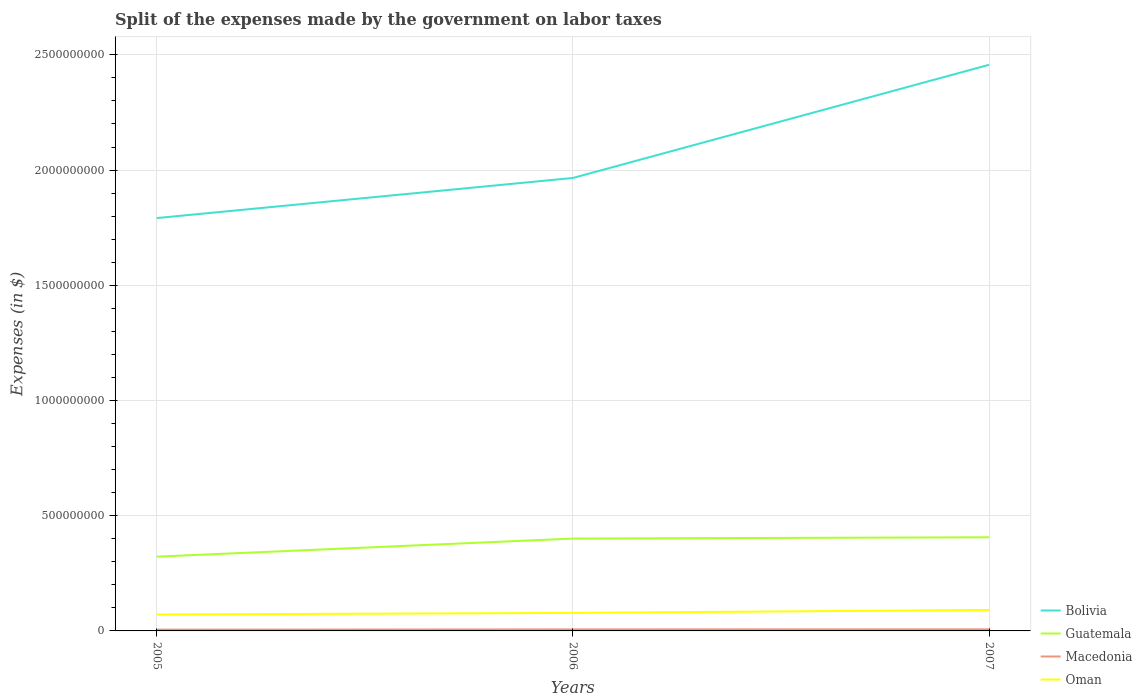Across all years, what is the maximum expenses made by the government on labor taxes in Oman?
Ensure brevity in your answer.  7.12e+07. What is the total expenses made by the government on labor taxes in Macedonia in the graph?
Ensure brevity in your answer.  -9.33e+05. What is the difference between the highest and the second highest expenses made by the government on labor taxes in Guatemala?
Provide a succinct answer. 8.40e+07. Is the expenses made by the government on labor taxes in Guatemala strictly greater than the expenses made by the government on labor taxes in Macedonia over the years?
Give a very brief answer. No. How many lines are there?
Keep it short and to the point. 4. How many years are there in the graph?
Your answer should be compact. 3. Are the values on the major ticks of Y-axis written in scientific E-notation?
Provide a short and direct response. No. Does the graph contain grids?
Your answer should be compact. Yes. Where does the legend appear in the graph?
Make the answer very short. Bottom right. How are the legend labels stacked?
Give a very brief answer. Vertical. What is the title of the graph?
Your answer should be compact. Split of the expenses made by the government on labor taxes. Does "Sint Maarten (Dutch part)" appear as one of the legend labels in the graph?
Offer a terse response. No. What is the label or title of the X-axis?
Your response must be concise. Years. What is the label or title of the Y-axis?
Provide a succinct answer. Expenses (in $). What is the Expenses (in $) of Bolivia in 2005?
Provide a succinct answer. 1.79e+09. What is the Expenses (in $) of Guatemala in 2005?
Make the answer very short. 3.22e+08. What is the Expenses (in $) of Macedonia in 2005?
Your answer should be very brief. 5.64e+06. What is the Expenses (in $) in Oman in 2005?
Offer a terse response. 7.12e+07. What is the Expenses (in $) of Bolivia in 2006?
Make the answer very short. 1.97e+09. What is the Expenses (in $) in Guatemala in 2006?
Keep it short and to the point. 4.01e+08. What is the Expenses (in $) of Macedonia in 2006?
Your answer should be very brief. 6.58e+06. What is the Expenses (in $) in Oman in 2006?
Offer a very short reply. 7.82e+07. What is the Expenses (in $) in Bolivia in 2007?
Provide a short and direct response. 2.46e+09. What is the Expenses (in $) of Guatemala in 2007?
Offer a very short reply. 4.06e+08. What is the Expenses (in $) in Macedonia in 2007?
Ensure brevity in your answer.  6.93e+06. What is the Expenses (in $) in Oman in 2007?
Ensure brevity in your answer.  9.09e+07. Across all years, what is the maximum Expenses (in $) in Bolivia?
Make the answer very short. 2.46e+09. Across all years, what is the maximum Expenses (in $) of Guatemala?
Your response must be concise. 4.06e+08. Across all years, what is the maximum Expenses (in $) in Macedonia?
Offer a very short reply. 6.93e+06. Across all years, what is the maximum Expenses (in $) of Oman?
Offer a terse response. 9.09e+07. Across all years, what is the minimum Expenses (in $) of Bolivia?
Your answer should be compact. 1.79e+09. Across all years, what is the minimum Expenses (in $) in Guatemala?
Your answer should be very brief. 3.22e+08. Across all years, what is the minimum Expenses (in $) in Macedonia?
Your response must be concise. 5.64e+06. Across all years, what is the minimum Expenses (in $) in Oman?
Give a very brief answer. 7.12e+07. What is the total Expenses (in $) of Bolivia in the graph?
Ensure brevity in your answer.  6.21e+09. What is the total Expenses (in $) of Guatemala in the graph?
Provide a short and direct response. 1.13e+09. What is the total Expenses (in $) of Macedonia in the graph?
Offer a very short reply. 1.92e+07. What is the total Expenses (in $) of Oman in the graph?
Provide a short and direct response. 2.40e+08. What is the difference between the Expenses (in $) of Bolivia in 2005 and that in 2006?
Make the answer very short. -1.74e+08. What is the difference between the Expenses (in $) in Guatemala in 2005 and that in 2006?
Your answer should be very brief. -7.84e+07. What is the difference between the Expenses (in $) of Macedonia in 2005 and that in 2006?
Your response must be concise. -9.33e+05. What is the difference between the Expenses (in $) of Oman in 2005 and that in 2006?
Keep it short and to the point. -7.00e+06. What is the difference between the Expenses (in $) of Bolivia in 2005 and that in 2007?
Make the answer very short. -6.65e+08. What is the difference between the Expenses (in $) of Guatemala in 2005 and that in 2007?
Your answer should be very brief. -8.40e+07. What is the difference between the Expenses (in $) in Macedonia in 2005 and that in 2007?
Offer a terse response. -1.29e+06. What is the difference between the Expenses (in $) of Oman in 2005 and that in 2007?
Your response must be concise. -1.97e+07. What is the difference between the Expenses (in $) in Bolivia in 2006 and that in 2007?
Provide a short and direct response. -4.91e+08. What is the difference between the Expenses (in $) in Guatemala in 2006 and that in 2007?
Your response must be concise. -5.60e+06. What is the difference between the Expenses (in $) in Macedonia in 2006 and that in 2007?
Offer a terse response. -3.58e+05. What is the difference between the Expenses (in $) of Oman in 2006 and that in 2007?
Give a very brief answer. -1.27e+07. What is the difference between the Expenses (in $) in Bolivia in 2005 and the Expenses (in $) in Guatemala in 2006?
Ensure brevity in your answer.  1.39e+09. What is the difference between the Expenses (in $) of Bolivia in 2005 and the Expenses (in $) of Macedonia in 2006?
Offer a very short reply. 1.79e+09. What is the difference between the Expenses (in $) in Bolivia in 2005 and the Expenses (in $) in Oman in 2006?
Provide a short and direct response. 1.71e+09. What is the difference between the Expenses (in $) in Guatemala in 2005 and the Expenses (in $) in Macedonia in 2006?
Provide a short and direct response. 3.16e+08. What is the difference between the Expenses (in $) in Guatemala in 2005 and the Expenses (in $) in Oman in 2006?
Keep it short and to the point. 2.44e+08. What is the difference between the Expenses (in $) in Macedonia in 2005 and the Expenses (in $) in Oman in 2006?
Your answer should be very brief. -7.26e+07. What is the difference between the Expenses (in $) of Bolivia in 2005 and the Expenses (in $) of Guatemala in 2007?
Make the answer very short. 1.39e+09. What is the difference between the Expenses (in $) of Bolivia in 2005 and the Expenses (in $) of Macedonia in 2007?
Your answer should be very brief. 1.78e+09. What is the difference between the Expenses (in $) in Bolivia in 2005 and the Expenses (in $) in Oman in 2007?
Your response must be concise. 1.70e+09. What is the difference between the Expenses (in $) of Guatemala in 2005 and the Expenses (in $) of Macedonia in 2007?
Your answer should be compact. 3.15e+08. What is the difference between the Expenses (in $) of Guatemala in 2005 and the Expenses (in $) of Oman in 2007?
Offer a terse response. 2.31e+08. What is the difference between the Expenses (in $) in Macedonia in 2005 and the Expenses (in $) in Oman in 2007?
Make the answer very short. -8.53e+07. What is the difference between the Expenses (in $) in Bolivia in 2006 and the Expenses (in $) in Guatemala in 2007?
Give a very brief answer. 1.56e+09. What is the difference between the Expenses (in $) in Bolivia in 2006 and the Expenses (in $) in Macedonia in 2007?
Your response must be concise. 1.96e+09. What is the difference between the Expenses (in $) of Bolivia in 2006 and the Expenses (in $) of Oman in 2007?
Your answer should be very brief. 1.87e+09. What is the difference between the Expenses (in $) of Guatemala in 2006 and the Expenses (in $) of Macedonia in 2007?
Your answer should be compact. 3.94e+08. What is the difference between the Expenses (in $) of Guatemala in 2006 and the Expenses (in $) of Oman in 2007?
Ensure brevity in your answer.  3.10e+08. What is the difference between the Expenses (in $) in Macedonia in 2006 and the Expenses (in $) in Oman in 2007?
Your answer should be very brief. -8.43e+07. What is the average Expenses (in $) in Bolivia per year?
Offer a very short reply. 2.07e+09. What is the average Expenses (in $) in Guatemala per year?
Give a very brief answer. 3.77e+08. What is the average Expenses (in $) of Macedonia per year?
Keep it short and to the point. 6.38e+06. What is the average Expenses (in $) in Oman per year?
Offer a terse response. 8.01e+07. In the year 2005, what is the difference between the Expenses (in $) of Bolivia and Expenses (in $) of Guatemala?
Keep it short and to the point. 1.47e+09. In the year 2005, what is the difference between the Expenses (in $) in Bolivia and Expenses (in $) in Macedonia?
Your answer should be compact. 1.79e+09. In the year 2005, what is the difference between the Expenses (in $) of Bolivia and Expenses (in $) of Oman?
Your answer should be compact. 1.72e+09. In the year 2005, what is the difference between the Expenses (in $) in Guatemala and Expenses (in $) in Macedonia?
Ensure brevity in your answer.  3.17e+08. In the year 2005, what is the difference between the Expenses (in $) of Guatemala and Expenses (in $) of Oman?
Provide a succinct answer. 2.51e+08. In the year 2005, what is the difference between the Expenses (in $) of Macedonia and Expenses (in $) of Oman?
Your answer should be compact. -6.56e+07. In the year 2006, what is the difference between the Expenses (in $) of Bolivia and Expenses (in $) of Guatemala?
Give a very brief answer. 1.56e+09. In the year 2006, what is the difference between the Expenses (in $) in Bolivia and Expenses (in $) in Macedonia?
Your answer should be very brief. 1.96e+09. In the year 2006, what is the difference between the Expenses (in $) in Bolivia and Expenses (in $) in Oman?
Offer a terse response. 1.89e+09. In the year 2006, what is the difference between the Expenses (in $) of Guatemala and Expenses (in $) of Macedonia?
Ensure brevity in your answer.  3.94e+08. In the year 2006, what is the difference between the Expenses (in $) of Guatemala and Expenses (in $) of Oman?
Ensure brevity in your answer.  3.23e+08. In the year 2006, what is the difference between the Expenses (in $) of Macedonia and Expenses (in $) of Oman?
Your answer should be compact. -7.16e+07. In the year 2007, what is the difference between the Expenses (in $) of Bolivia and Expenses (in $) of Guatemala?
Ensure brevity in your answer.  2.05e+09. In the year 2007, what is the difference between the Expenses (in $) of Bolivia and Expenses (in $) of Macedonia?
Offer a terse response. 2.45e+09. In the year 2007, what is the difference between the Expenses (in $) of Bolivia and Expenses (in $) of Oman?
Provide a succinct answer. 2.37e+09. In the year 2007, what is the difference between the Expenses (in $) in Guatemala and Expenses (in $) in Macedonia?
Provide a short and direct response. 3.99e+08. In the year 2007, what is the difference between the Expenses (in $) of Guatemala and Expenses (in $) of Oman?
Make the answer very short. 3.16e+08. In the year 2007, what is the difference between the Expenses (in $) of Macedonia and Expenses (in $) of Oman?
Your answer should be very brief. -8.40e+07. What is the ratio of the Expenses (in $) of Bolivia in 2005 to that in 2006?
Make the answer very short. 0.91. What is the ratio of the Expenses (in $) of Guatemala in 2005 to that in 2006?
Keep it short and to the point. 0.8. What is the ratio of the Expenses (in $) of Macedonia in 2005 to that in 2006?
Your response must be concise. 0.86. What is the ratio of the Expenses (in $) of Oman in 2005 to that in 2006?
Ensure brevity in your answer.  0.91. What is the ratio of the Expenses (in $) of Bolivia in 2005 to that in 2007?
Ensure brevity in your answer.  0.73. What is the ratio of the Expenses (in $) in Guatemala in 2005 to that in 2007?
Your answer should be compact. 0.79. What is the ratio of the Expenses (in $) in Macedonia in 2005 to that in 2007?
Ensure brevity in your answer.  0.81. What is the ratio of the Expenses (in $) of Oman in 2005 to that in 2007?
Provide a short and direct response. 0.78. What is the ratio of the Expenses (in $) of Bolivia in 2006 to that in 2007?
Your answer should be compact. 0.8. What is the ratio of the Expenses (in $) of Guatemala in 2006 to that in 2007?
Make the answer very short. 0.99. What is the ratio of the Expenses (in $) of Macedonia in 2006 to that in 2007?
Provide a succinct answer. 0.95. What is the ratio of the Expenses (in $) of Oman in 2006 to that in 2007?
Your response must be concise. 0.86. What is the difference between the highest and the second highest Expenses (in $) of Bolivia?
Offer a very short reply. 4.91e+08. What is the difference between the highest and the second highest Expenses (in $) in Guatemala?
Offer a terse response. 5.60e+06. What is the difference between the highest and the second highest Expenses (in $) of Macedonia?
Your answer should be very brief. 3.58e+05. What is the difference between the highest and the second highest Expenses (in $) in Oman?
Your response must be concise. 1.27e+07. What is the difference between the highest and the lowest Expenses (in $) of Bolivia?
Provide a short and direct response. 6.65e+08. What is the difference between the highest and the lowest Expenses (in $) in Guatemala?
Keep it short and to the point. 8.40e+07. What is the difference between the highest and the lowest Expenses (in $) in Macedonia?
Keep it short and to the point. 1.29e+06. What is the difference between the highest and the lowest Expenses (in $) of Oman?
Your response must be concise. 1.97e+07. 